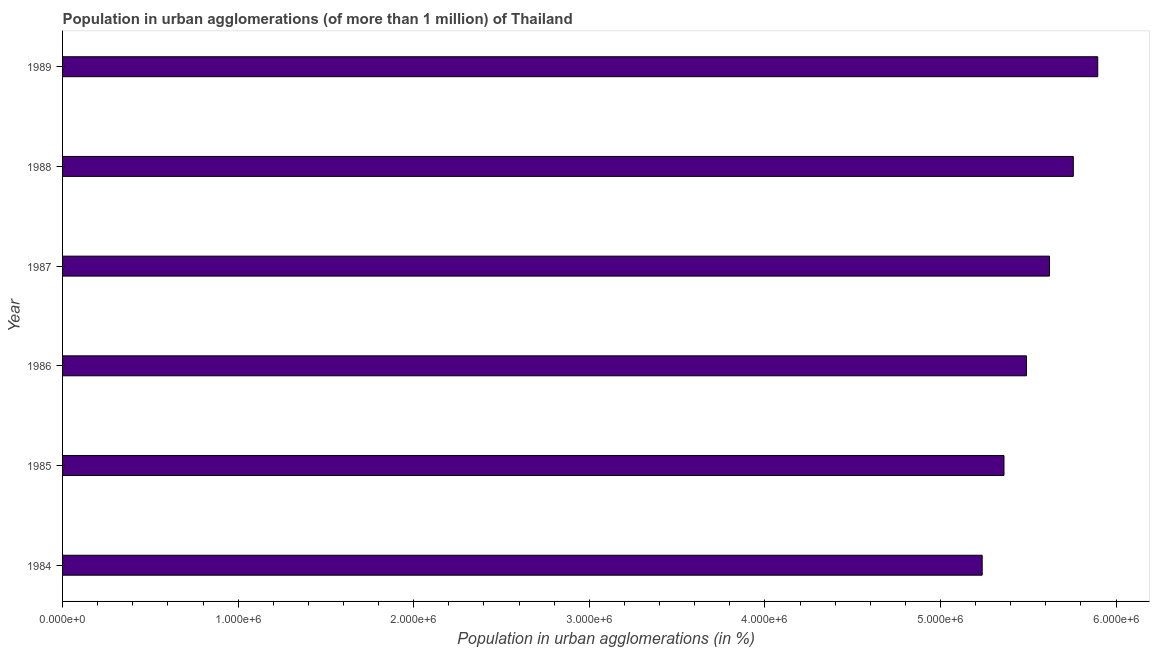Does the graph contain any zero values?
Ensure brevity in your answer.  No. Does the graph contain grids?
Ensure brevity in your answer.  No. What is the title of the graph?
Provide a short and direct response. Population in urban agglomerations (of more than 1 million) of Thailand. What is the label or title of the X-axis?
Provide a short and direct response. Population in urban agglomerations (in %). What is the population in urban agglomerations in 1984?
Make the answer very short. 5.24e+06. Across all years, what is the maximum population in urban agglomerations?
Keep it short and to the point. 5.90e+06. Across all years, what is the minimum population in urban agglomerations?
Offer a very short reply. 5.24e+06. What is the sum of the population in urban agglomerations?
Offer a very short reply. 3.34e+07. What is the difference between the population in urban agglomerations in 1985 and 1986?
Your answer should be very brief. -1.28e+05. What is the average population in urban agglomerations per year?
Ensure brevity in your answer.  5.56e+06. What is the median population in urban agglomerations?
Your answer should be compact. 5.56e+06. Do a majority of the years between 1987 and 1988 (inclusive) have population in urban agglomerations greater than 4200000 %?
Offer a very short reply. Yes. What is the ratio of the population in urban agglomerations in 1984 to that in 1986?
Your answer should be compact. 0.95. Is the population in urban agglomerations in 1986 less than that in 1989?
Your answer should be very brief. Yes. What is the difference between the highest and the second highest population in urban agglomerations?
Your response must be concise. 1.39e+05. Is the sum of the population in urban agglomerations in 1984 and 1989 greater than the maximum population in urban agglomerations across all years?
Provide a succinct answer. Yes. What is the difference between the highest and the lowest population in urban agglomerations?
Give a very brief answer. 6.58e+05. How many bars are there?
Your answer should be very brief. 6. What is the difference between two consecutive major ticks on the X-axis?
Make the answer very short. 1.00e+06. What is the Population in urban agglomerations (in %) of 1984?
Offer a very short reply. 5.24e+06. What is the Population in urban agglomerations (in %) of 1985?
Provide a short and direct response. 5.36e+06. What is the Population in urban agglomerations (in %) in 1986?
Your answer should be compact. 5.49e+06. What is the Population in urban agglomerations (in %) in 1987?
Provide a short and direct response. 5.62e+06. What is the Population in urban agglomerations (in %) of 1988?
Your answer should be very brief. 5.76e+06. What is the Population in urban agglomerations (in %) in 1989?
Give a very brief answer. 5.90e+06. What is the difference between the Population in urban agglomerations (in %) in 1984 and 1985?
Your answer should be very brief. -1.24e+05. What is the difference between the Population in urban agglomerations (in %) in 1984 and 1986?
Offer a very short reply. -2.52e+05. What is the difference between the Population in urban agglomerations (in %) in 1984 and 1987?
Provide a short and direct response. -3.83e+05. What is the difference between the Population in urban agglomerations (in %) in 1984 and 1988?
Provide a succinct answer. -5.19e+05. What is the difference between the Population in urban agglomerations (in %) in 1984 and 1989?
Your answer should be compact. -6.58e+05. What is the difference between the Population in urban agglomerations (in %) in 1985 and 1986?
Give a very brief answer. -1.28e+05. What is the difference between the Population in urban agglomerations (in %) in 1985 and 1987?
Give a very brief answer. -2.59e+05. What is the difference between the Population in urban agglomerations (in %) in 1985 and 1988?
Provide a succinct answer. -3.95e+05. What is the difference between the Population in urban agglomerations (in %) in 1985 and 1989?
Offer a terse response. -5.34e+05. What is the difference between the Population in urban agglomerations (in %) in 1986 and 1987?
Your response must be concise. -1.31e+05. What is the difference between the Population in urban agglomerations (in %) in 1986 and 1988?
Offer a terse response. -2.67e+05. What is the difference between the Population in urban agglomerations (in %) in 1986 and 1989?
Give a very brief answer. -4.06e+05. What is the difference between the Population in urban agglomerations (in %) in 1987 and 1988?
Provide a short and direct response. -1.35e+05. What is the difference between the Population in urban agglomerations (in %) in 1987 and 1989?
Your answer should be very brief. -2.75e+05. What is the difference between the Population in urban agglomerations (in %) in 1988 and 1989?
Your answer should be very brief. -1.39e+05. What is the ratio of the Population in urban agglomerations (in %) in 1984 to that in 1986?
Your response must be concise. 0.95. What is the ratio of the Population in urban agglomerations (in %) in 1984 to that in 1987?
Your response must be concise. 0.93. What is the ratio of the Population in urban agglomerations (in %) in 1984 to that in 1988?
Your response must be concise. 0.91. What is the ratio of the Population in urban agglomerations (in %) in 1984 to that in 1989?
Ensure brevity in your answer.  0.89. What is the ratio of the Population in urban agglomerations (in %) in 1985 to that in 1987?
Give a very brief answer. 0.95. What is the ratio of the Population in urban agglomerations (in %) in 1985 to that in 1989?
Make the answer very short. 0.91. What is the ratio of the Population in urban agglomerations (in %) in 1986 to that in 1988?
Make the answer very short. 0.95. What is the ratio of the Population in urban agglomerations (in %) in 1986 to that in 1989?
Keep it short and to the point. 0.93. What is the ratio of the Population in urban agglomerations (in %) in 1987 to that in 1989?
Offer a terse response. 0.95. What is the ratio of the Population in urban agglomerations (in %) in 1988 to that in 1989?
Your answer should be compact. 0.98. 